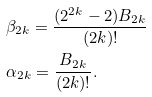<formula> <loc_0><loc_0><loc_500><loc_500>& \beta _ { 2 k } = \frac { ( 2 ^ { 2 k } - 2 ) B _ { 2 k } } { ( 2 k ) ! } \\ & \alpha _ { 2 k } = \frac { B _ { 2 k } } { ( 2 k ) ! } .</formula> 